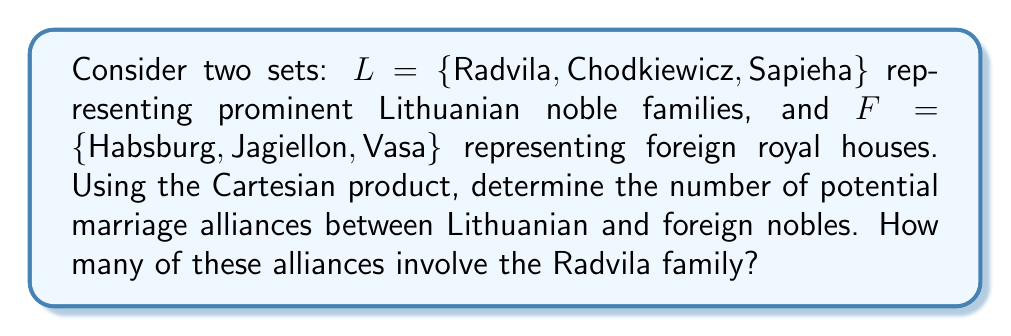Solve this math problem. To solve this problem, we'll use the concept of Cartesian product from set theory:

1) The Cartesian product of sets $L$ and $F$ is defined as:
   $L \times F = \{(l, f) : l \in L \text{ and } f \in F\}$

2) To find the total number of potential alliances, we need to calculate the cardinality of $L \times F$:
   $|L \times F| = |L| \cdot |F|$
   
   Where $|L| = 3$ and $|F| = 3$
   
   Therefore, $|L \times F| = 3 \cdot 3 = 9$

3) To find how many alliances involve the Radvila family, we need to count the elements in the Cartesian product where the first element is Radvila:
   $\{(Radvila, Habsburg), (Radvila, Jagiellon), (Radvila, Vasa)\}$

   This is equivalent to $|\{Radvila\} \times F| = 1 \cdot |F| = 1 \cdot 3 = 3$

This approach models potential marriage alliances as pairs of families, allowing historians to systematically analyze possible diplomatic connections in 16th century Eastern European nobility.
Answer: There are 9 potential marriage alliances in total, of which 3 involve the Radvila family. 